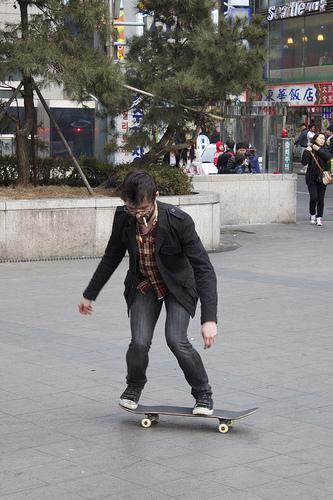How many people are skateboarding?
Give a very brief answer. 1. 